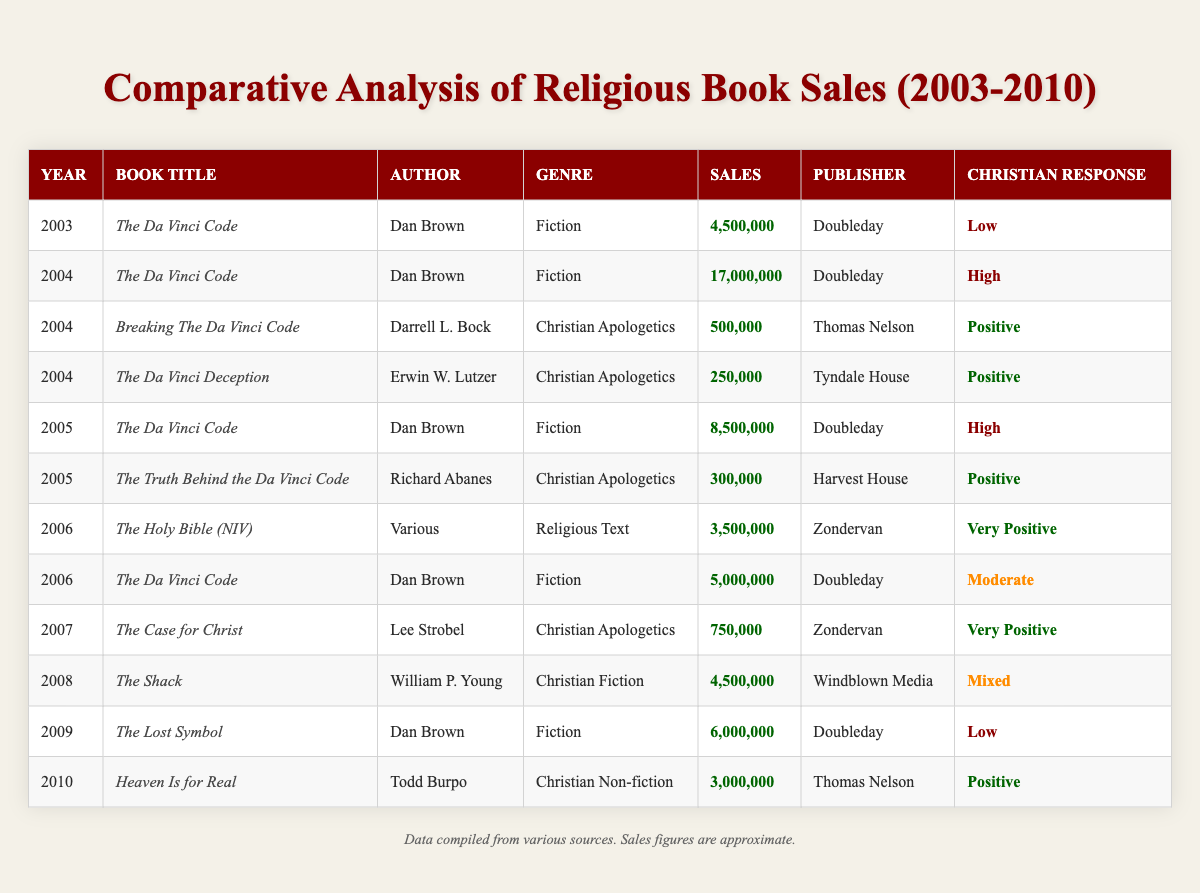What year had the highest sales for "The Da Vinci Code"? Looking at the sales data for each year, "The Da Vinci Code" had sales of 17,000,000 in 2004, which is the highest compared to other years listed.
Answer: 2004 In which year did "Heaven Is for Real" have sales, and what were those sales figures? "Heaven Is for Real" was published in 2010 with sales figures of 3,000,000, as indicated in the table.
Answer: 2010, 3,000,000 What is the total sales of all books classified as "Christian Apologetics"? The sales for the books under "Christian Apologetics" are 500,000 (2004), 250,000 (2004), 300,000 (2005), and 750,000 (2007). Adding these gives a total of 1,800,000.
Answer: 1,800,000 Is "The Da Vinci Code" categorized as Christian apologetics? "The Da Vinci Code" is classified as a work of fiction and not as Christian apologetics, as seen from its genre listing in the table.
Answer: No Which book had the highest response from the Christian community, and what was that response? The highest response was for "The Holy Bible (NIV)" in 2006, which received a "Very Positive" response from the Christian community.
Answer: The Holy Bible (NIV), Very Positive What is the average sales figure for all instances of "The Da Vinci Code"? The sales figures for "The Da Vinci Code" across the years are 4,500,000 (2003), 17,000,000 (2004), 8,500,000 (2005), and 5,000,000 (2006). The total sales are 35,000,000, and dividing by the number of instances (4) gives an average of 8,750,000.
Answer: 8,750,000 In which genre did "The Case for Christ" fall, and what were its sales? "The Case for Christ" is categorized under "Christian Apologetics" and had sales of 750,000, as noted in the data.
Answer: Christian Apologetics, 750,000 What was the Christian community's response to "The Lost Symbol"? The response for "The Lost Symbol" in 2009 was categorized as "Low", as stated in the table.
Answer: Low 